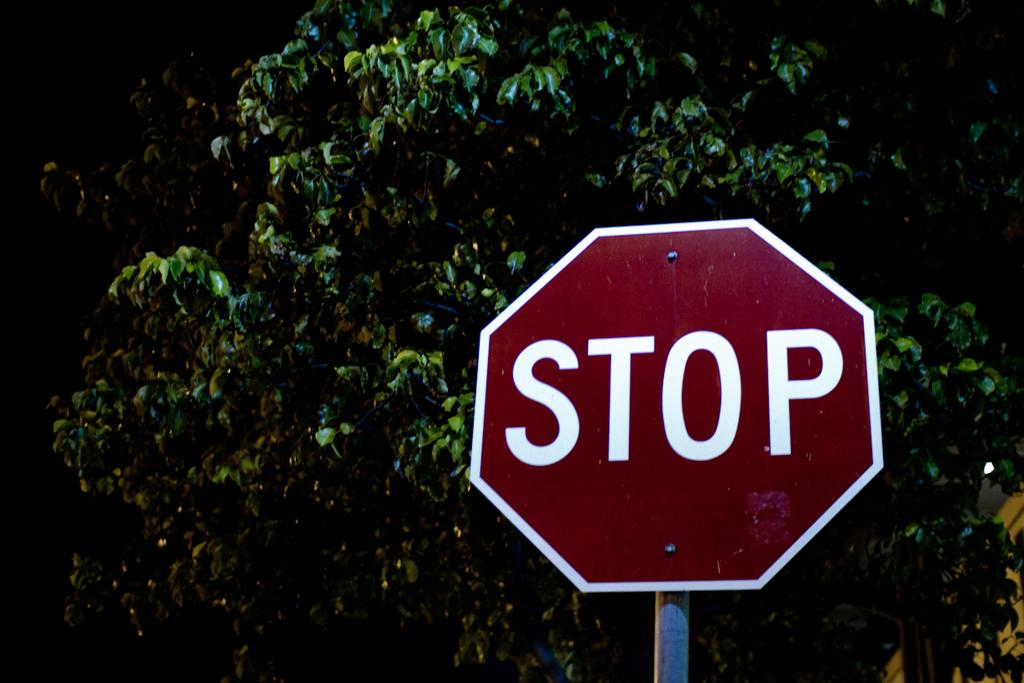<image>
Render a clear and concise summary of the photo. A red sign that reads STOP outside a tree area 